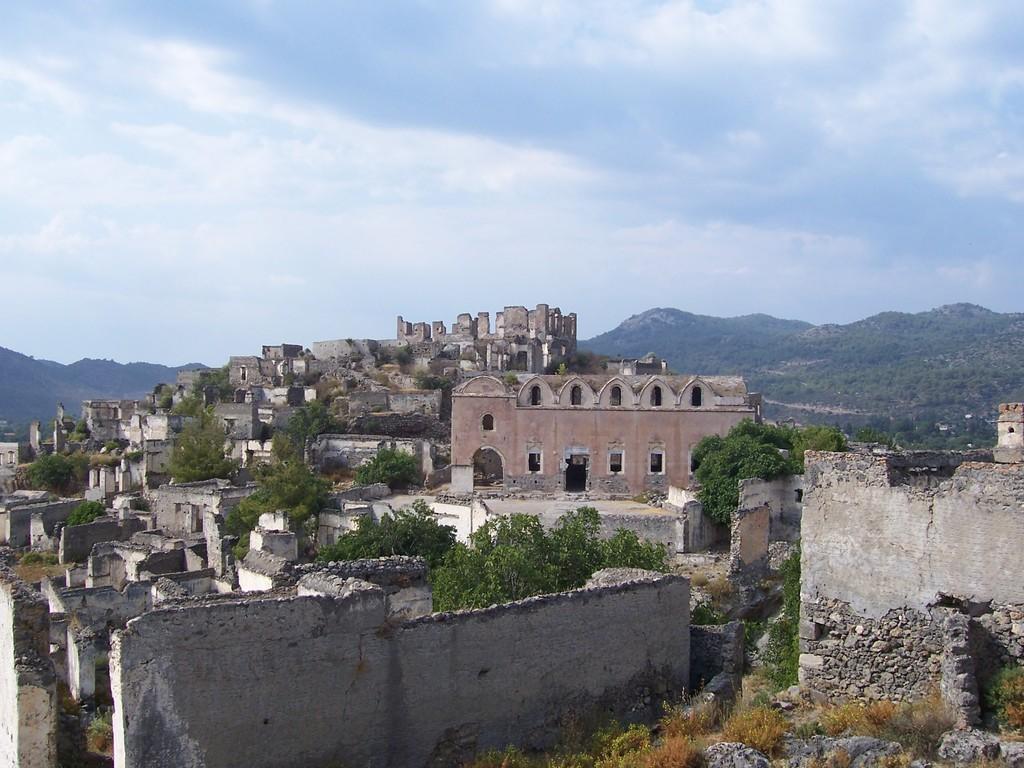Please provide a concise description of this image. In this image, there are a few houses. We can also see some trees, grass and rocks. We can also see the hills. We can see the sky with clouds. 